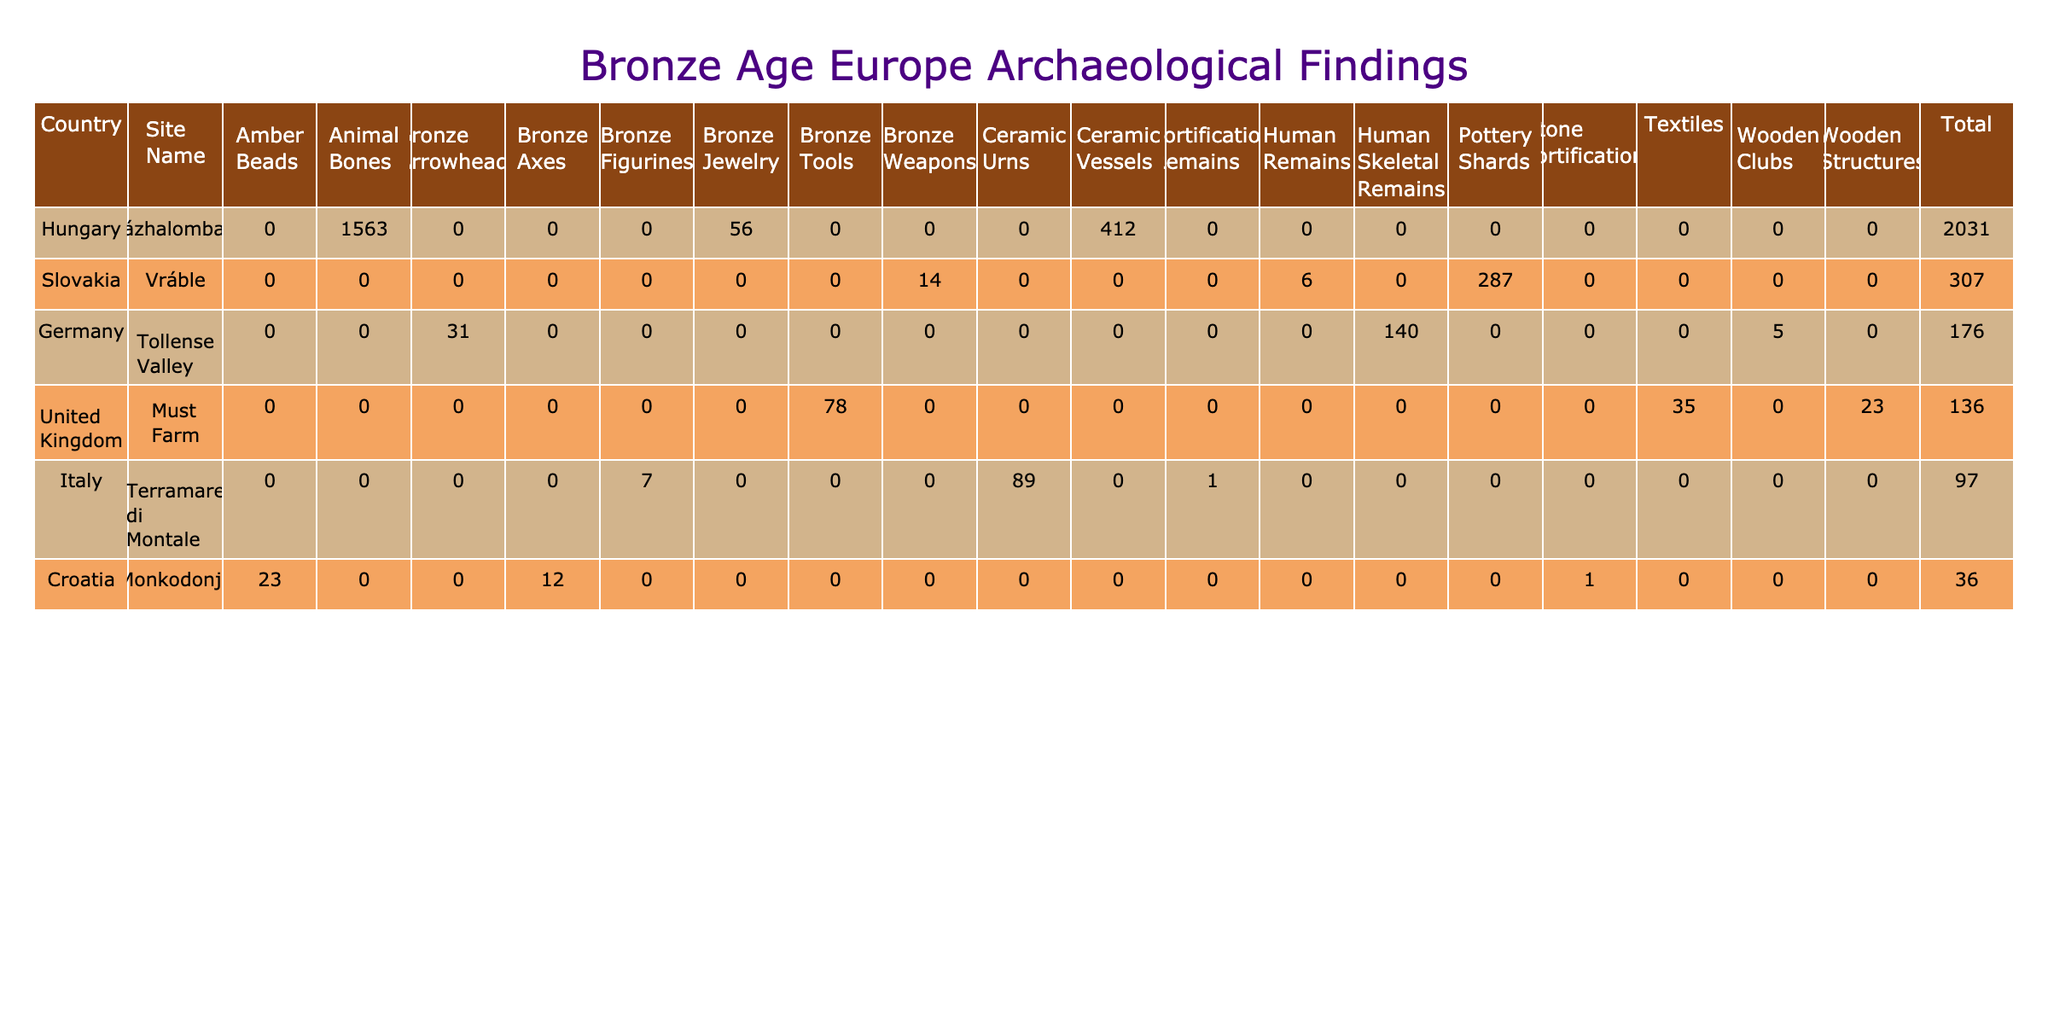What is the total quantity of artifacts found at Százhalombatta, Hungary? To find the total quantity of artifacts from Százhalombatta, I can look at the rows corresponding to Százhalombatta in the table and sum up the quantities for each artifact type listed. The quantities for Ceramics Vessels, Animal Bones, and Bronze Jewelry are 412, 1563, and 56, respectively. The total is calculated as 412 + 1563 + 56 = 2031.
Answer: 2031 Which site has the highest quantity of Bronze Weapons found? I can compare the quantities of Bronze Weapons across the listed sites. The only site with Bronze Weapons is Vráble, Slovakia, with a quantity of 14, while there are no Bronze Weapons recorded at the other sites. Therefore, Vráble must have the highest quantity of Bronze Weapons found.
Answer: Vráble, Slovakia Is there any site where the quantity of Human Remains is more than 100? I review the quantities of Human Remains across the sites. The table shows that Tollense Valley, Germany has 140 Human Skeletal Remains, while Vráble, Slovakia has only 6. Since 140 is greater than 100, the answer is yes.
Answer: Yes What is the average quantity of artifacts excavated from sites in Germany? To calculate the average quantity from Germany, I’ll identify the sites from this country: Tollense Valley, which has 140 Human Skeletal Remains, 5 Wooden Clubs, and 31 Bronze Arrowheads. The total quantity is 140 + 5 + 31 = 176. There are 3 records, so the average is 176 / 3 = 58.67.
Answer: 58.67 Which country had the highest total quantity of artifacts found, and what was that total? I will calculate the total quantity of artifacts for each country by summing the respective quantities. For Slovakia (287 + 14 + 6 = 307), United Kingdom (23 + 35 + 78 = 136), Hungary (412 + 1563 + 56 = 2031), Italy (1 + 7 + 89 = 97), Germany (140 + 5 + 31 = 176), and Croatia (1 + 12 + 23 = 36). The highest total is from Hungary with 2031 artifacts.
Answer: Hungary, 2031 